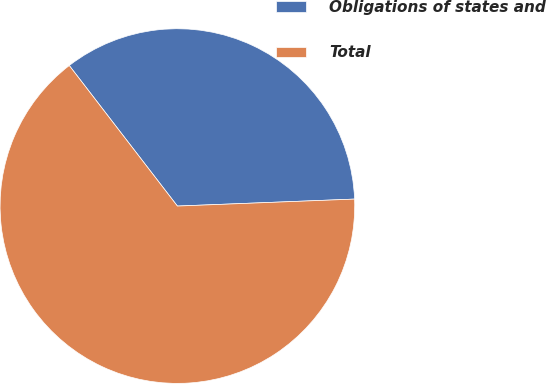Convert chart. <chart><loc_0><loc_0><loc_500><loc_500><pie_chart><fcel>Obligations of states and<fcel>Total<nl><fcel>34.81%<fcel>65.19%<nl></chart> 